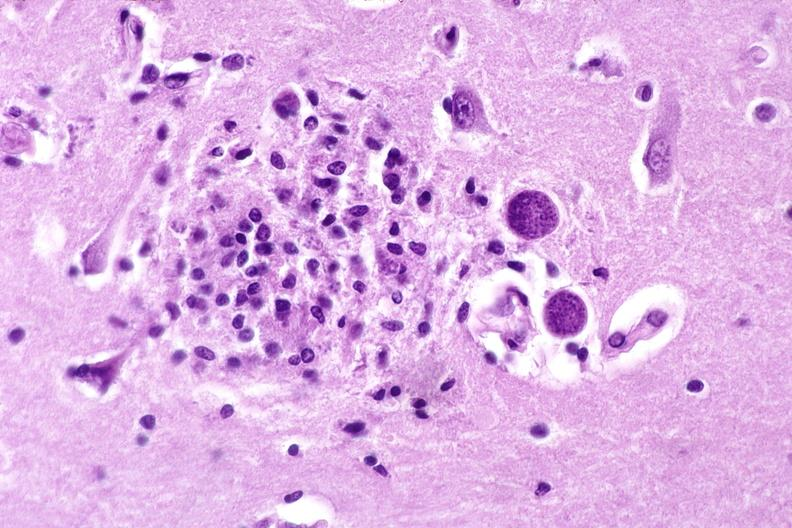s nervous present?
Answer the question using a single word or phrase. Yes 